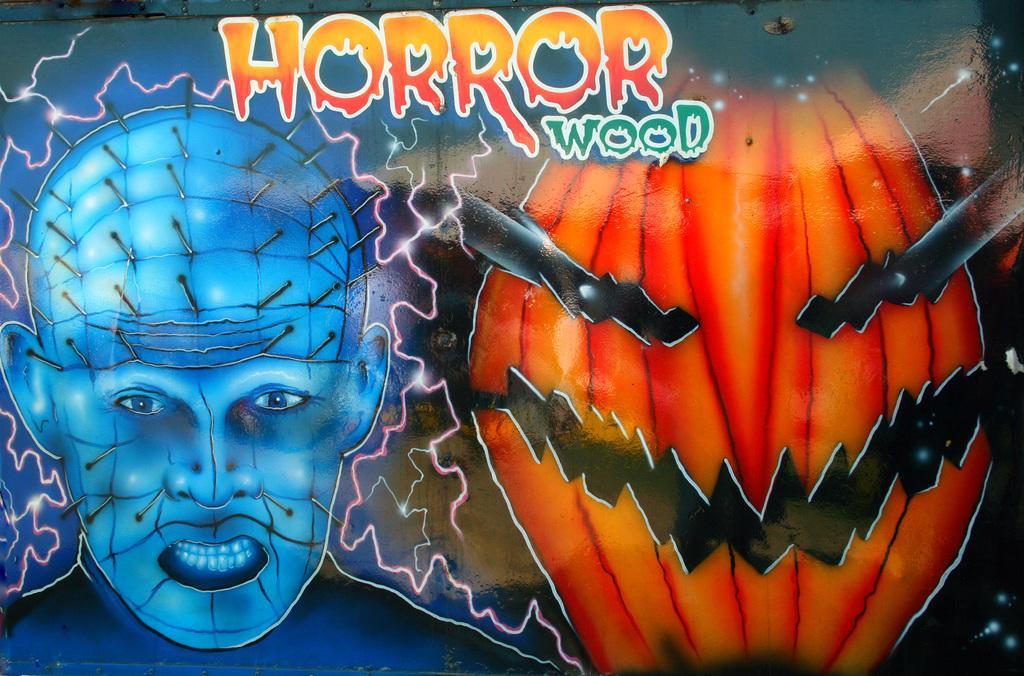In one or two sentences, can you explain what this image depicts? In this graphic image there are pictures and text on it. 